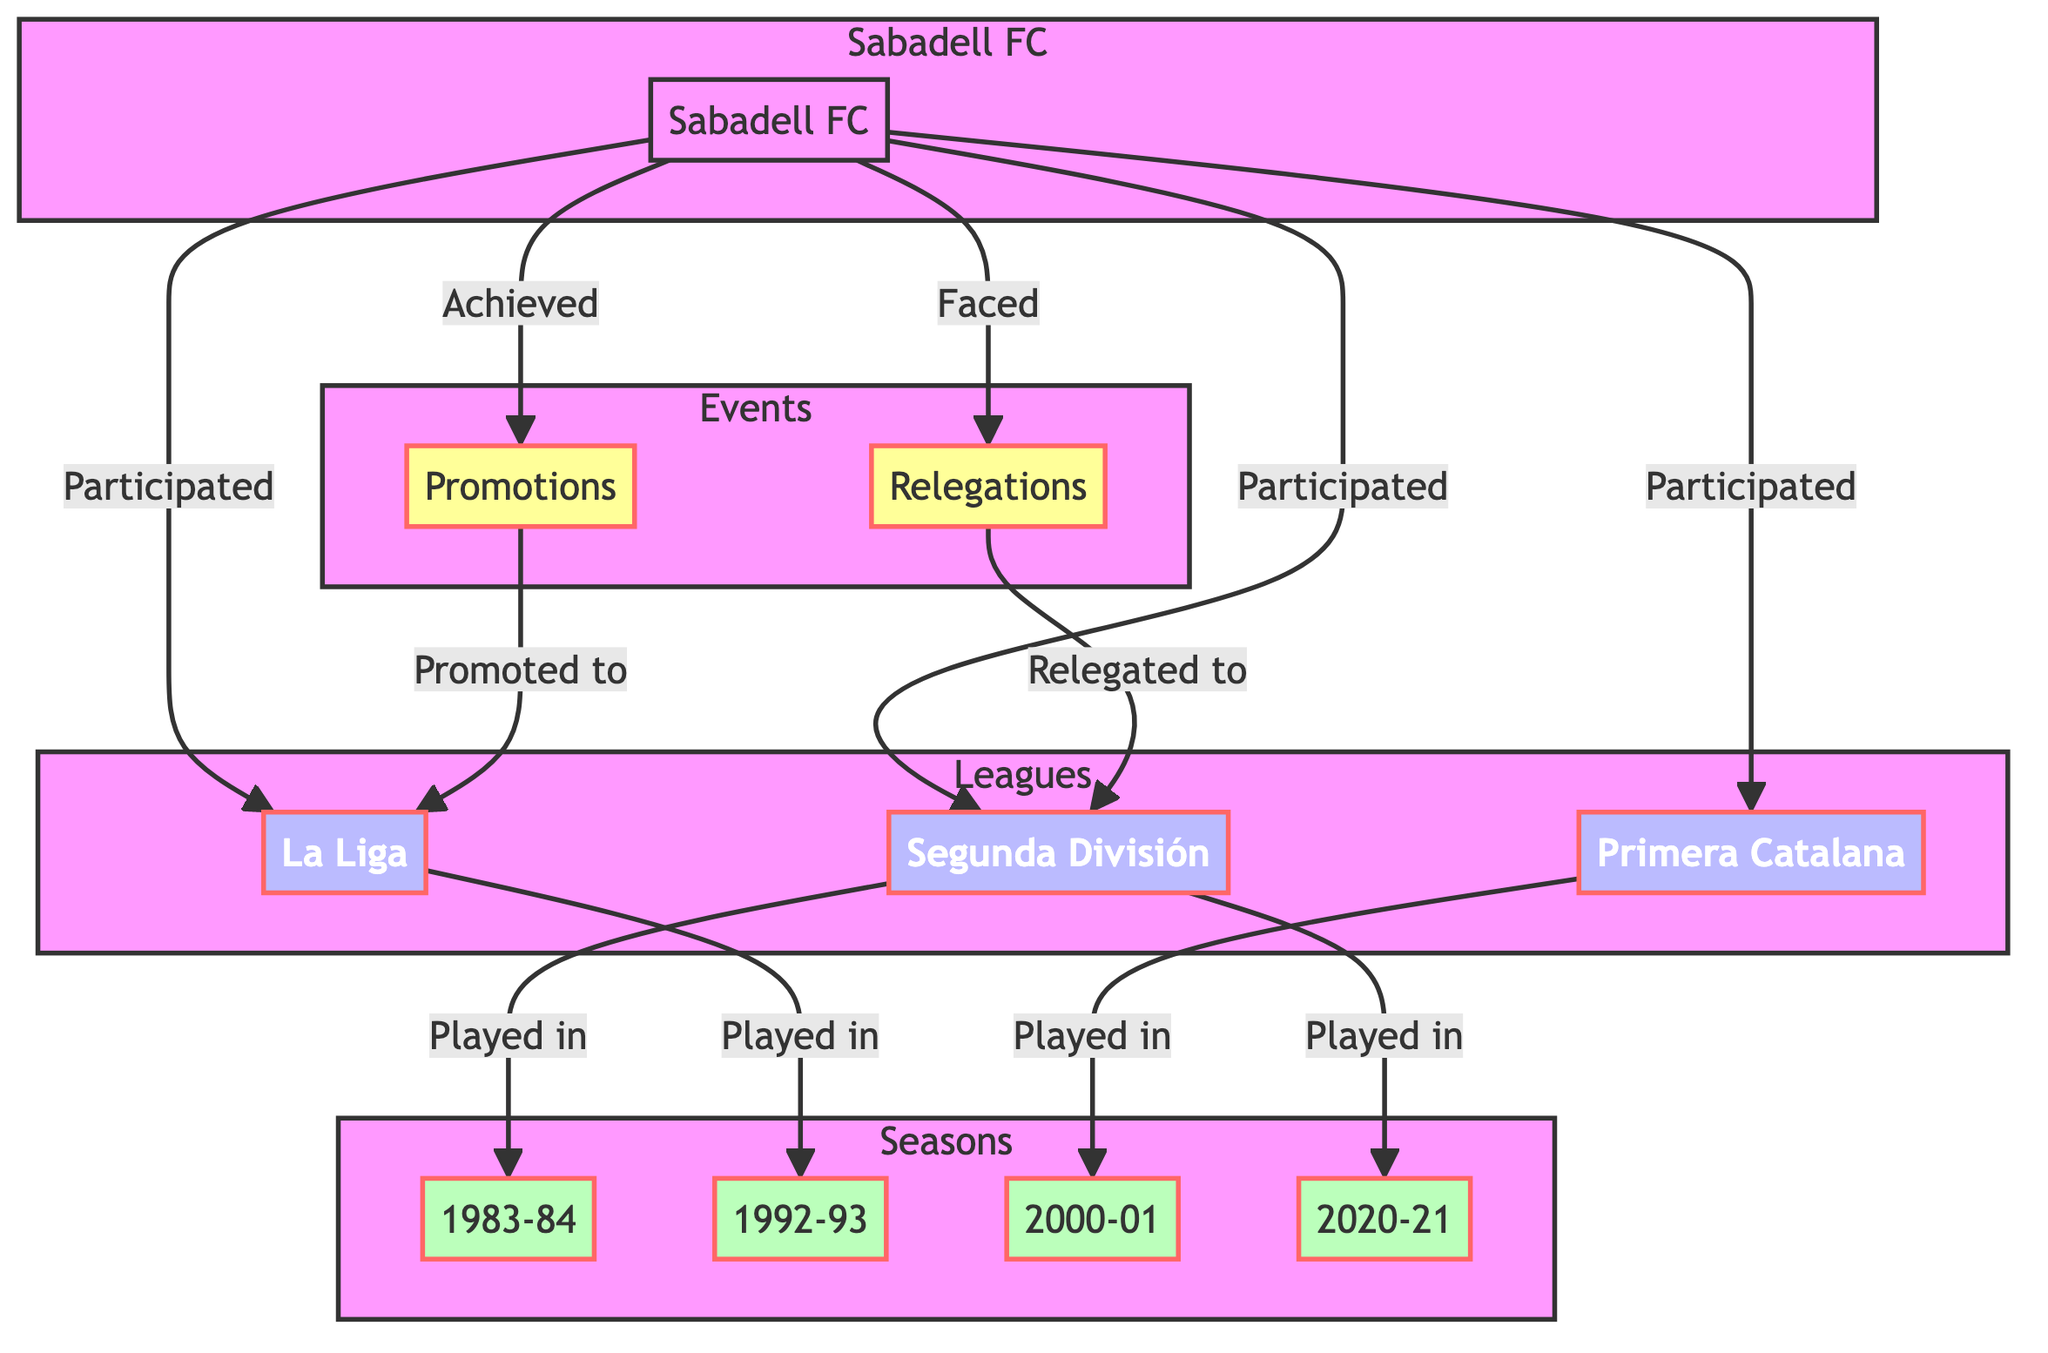What club is represented in the diagram? The diagram is centered around one club, "Sabadell FC," which is the only node of the type "club."
Answer: Sabadell FC How many leagues did Sabadell FC participate in? Sabadell FC is connected to three leagues: "Segunda División," "La Liga," and "Primera Catalana," indicating their participation in three leagues.
Answer: 3 What event did Sabadell FC achieve? The diagram indicates that Sabadell FC "Achieved" Promotions, which is the only event they are connected to for achievement.
Answer: Promotions In which season did Sabadell FC play in La Liga? The connection shows that they "Played in" La Liga during the "1992-93 Season." Hence, the specific season is found within the edges linked to La Liga.
Answer: 1992-93 Season What was the outcome for Sabadell FC in the 2000-01 season? Looking at the connections, Sabadell FC "Played in" the Primera Catalana during the 2000-01 Season, revealing their performance in that specific season.
Answer: Played in Primera Catalana What league did Sabadell FC face relegation to? The diagram illustrates that after facing relegation, Sabadell FC was "Relegated to" the "Segunda División." The relationships through the events lead to this conclusion.
Answer: Segunda División How many seasons are listed in the diagram? The diagram contains four seasons: "1983-84 Season," "1992-93 Season," "2000-01 Season," and "2020-21 Season," thus showing four distinct seasons.
Answer: 4 What type of relationship does Sabadell FC have with the events? Sabadell FC has two types of relationships with events: "Achieved" for Promotions and "Faced" for Relegations; thus, they are directly associated with these two events.
Answer: Achieved and Faced Which season is linked to the Primera Catalana? The diagram specifies that "2000-01 Season" is directly linked to the "Played in" relationship with the league known as "Primera Catalana."
Answer: 2000-01 Season 